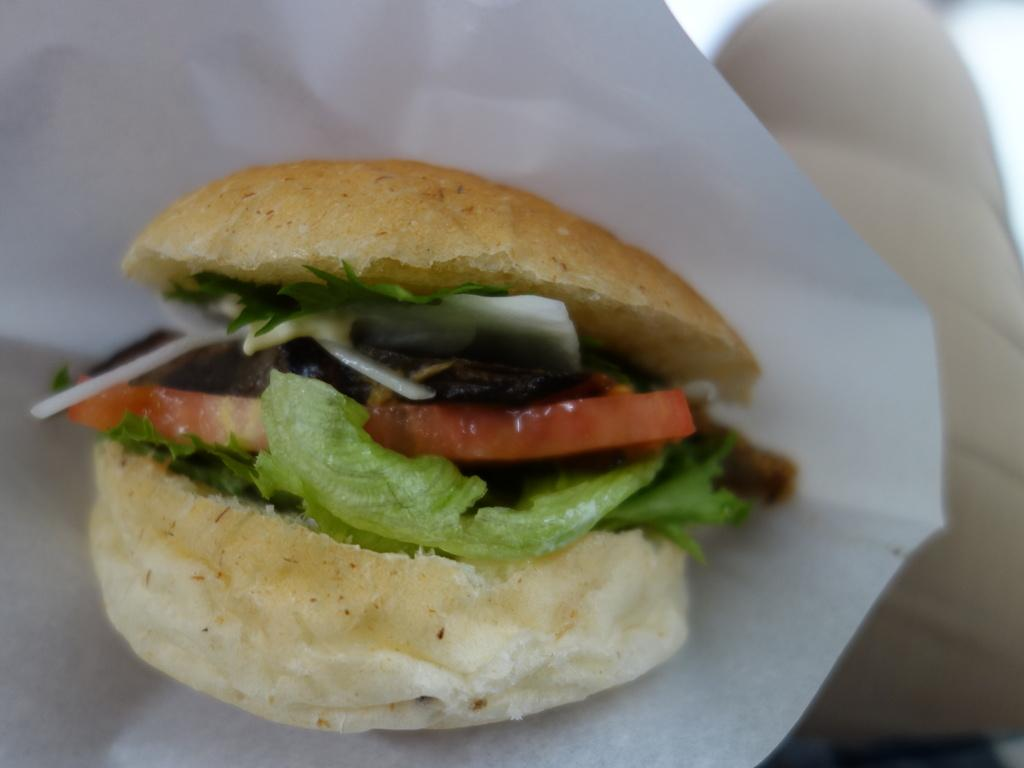What type of food is the image contains? There is a burger in the image. What is the burger placed on? The burger is on a white paper. Can you describe the background of the image? The background of the image is blurry. What type of bushes can be seen in the image? There are no bushes present in the image; it only contains a burger on a white paper with a blurry background. 